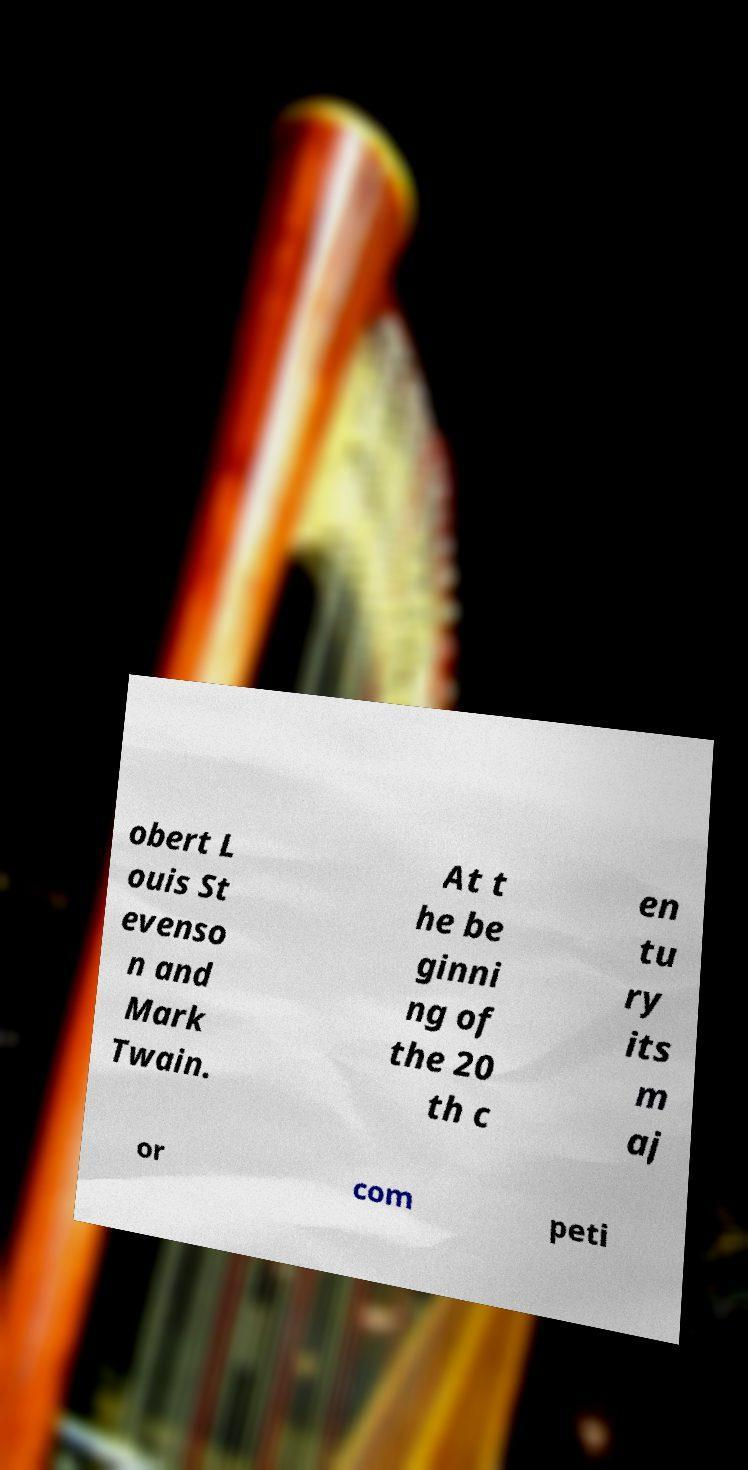For documentation purposes, I need the text within this image transcribed. Could you provide that? obert L ouis St evenso n and Mark Twain. At t he be ginni ng of the 20 th c en tu ry its m aj or com peti 